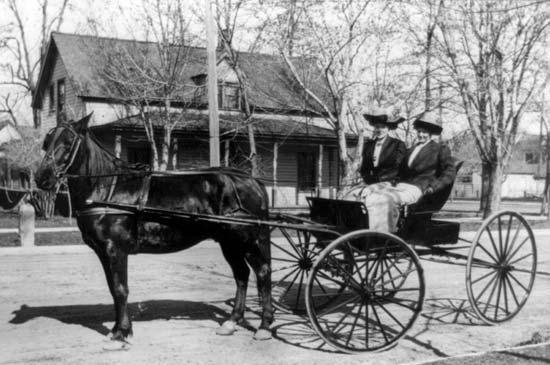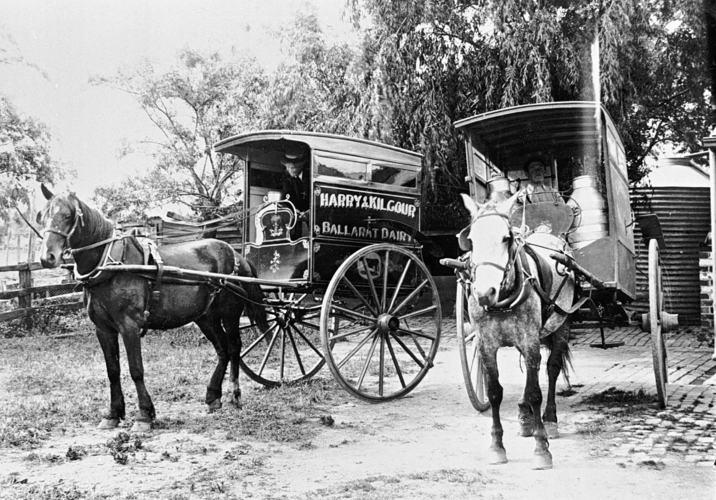The first image is the image on the left, the second image is the image on the right. Given the left and right images, does the statement "The left image shows a two-wheeled wagon with no passengers." hold true? Answer yes or no. No. The first image is the image on the left, the second image is the image on the right. Analyze the images presented: Is the assertion "Two horses are pulling a single cart in the image on the right." valid? Answer yes or no. No. 